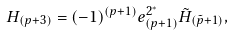Convert formula to latex. <formula><loc_0><loc_0><loc_500><loc_500>H _ { ( p + 3 ) } = ( - 1 ) ^ { ( p + 1 ) } e _ { ( p + 1 ) } ^ { 2 ^ { * } } \tilde { H } _ { ( \tilde { p } + 1 ) } ,</formula> 